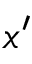Convert formula to latex. <formula><loc_0><loc_0><loc_500><loc_500>x ^ { \prime }</formula> 